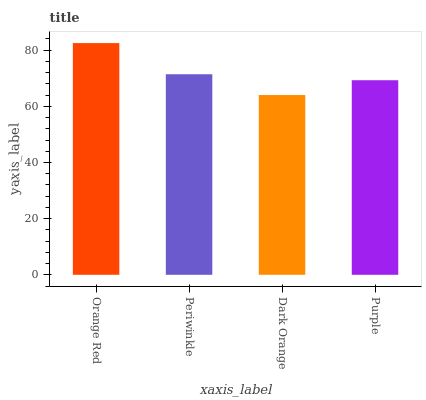Is Dark Orange the minimum?
Answer yes or no. Yes. Is Orange Red the maximum?
Answer yes or no. Yes. Is Periwinkle the minimum?
Answer yes or no. No. Is Periwinkle the maximum?
Answer yes or no. No. Is Orange Red greater than Periwinkle?
Answer yes or no. Yes. Is Periwinkle less than Orange Red?
Answer yes or no. Yes. Is Periwinkle greater than Orange Red?
Answer yes or no. No. Is Orange Red less than Periwinkle?
Answer yes or no. No. Is Periwinkle the high median?
Answer yes or no. Yes. Is Purple the low median?
Answer yes or no. Yes. Is Purple the high median?
Answer yes or no. No. Is Periwinkle the low median?
Answer yes or no. No. 